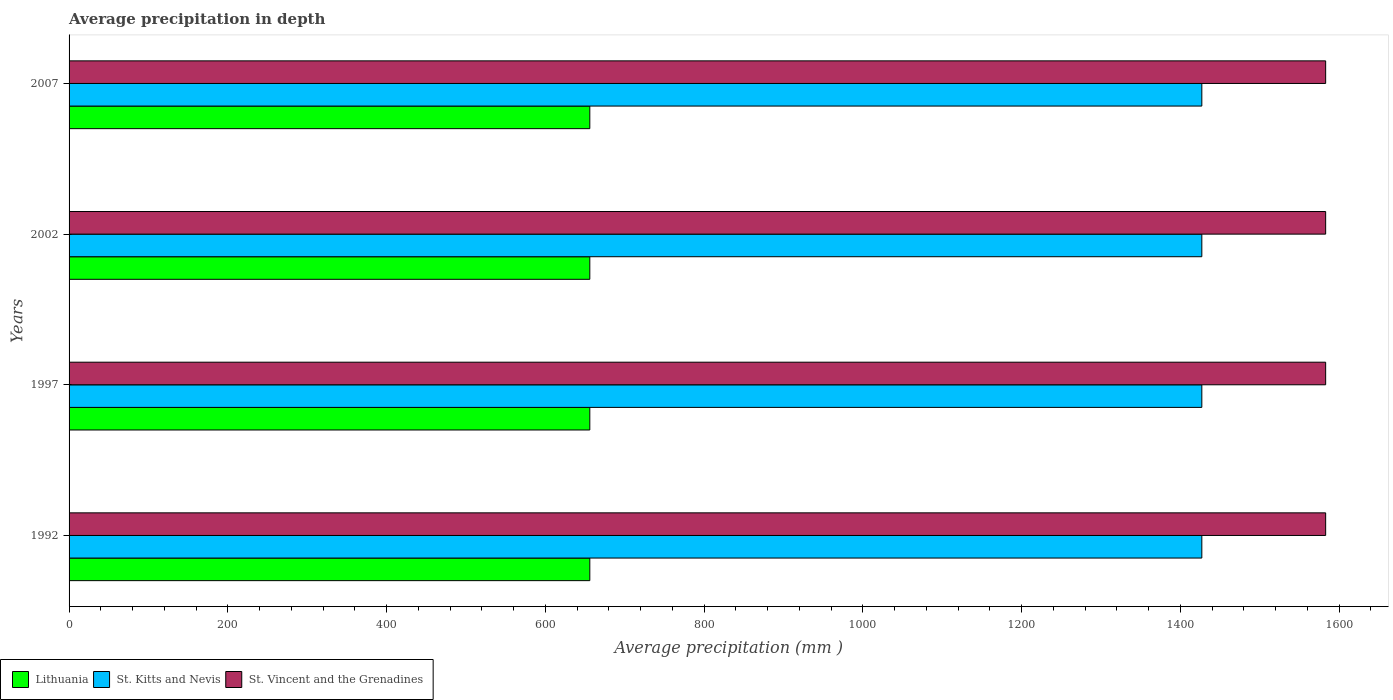How many groups of bars are there?
Keep it short and to the point. 4. What is the label of the 1st group of bars from the top?
Provide a succinct answer. 2007. What is the average precipitation in Lithuania in 2007?
Give a very brief answer. 656. Across all years, what is the maximum average precipitation in St. Kitts and Nevis?
Provide a succinct answer. 1427. Across all years, what is the minimum average precipitation in Lithuania?
Provide a short and direct response. 656. What is the total average precipitation in Lithuania in the graph?
Offer a very short reply. 2624. What is the difference between the average precipitation in St. Kitts and Nevis in 1992 and that in 1997?
Your answer should be compact. 0. What is the difference between the average precipitation in St. Vincent and the Grenadines in 2007 and the average precipitation in St. Kitts and Nevis in 1997?
Give a very brief answer. 156. What is the average average precipitation in St. Vincent and the Grenadines per year?
Keep it short and to the point. 1583. In the year 1997, what is the difference between the average precipitation in Lithuania and average precipitation in St. Kitts and Nevis?
Provide a succinct answer. -771. What is the difference between the highest and the lowest average precipitation in St. Kitts and Nevis?
Make the answer very short. 0. In how many years, is the average precipitation in St. Kitts and Nevis greater than the average average precipitation in St. Kitts and Nevis taken over all years?
Offer a very short reply. 0. Is the sum of the average precipitation in St. Kitts and Nevis in 1997 and 2002 greater than the maximum average precipitation in Lithuania across all years?
Keep it short and to the point. Yes. What does the 1st bar from the top in 2007 represents?
Your answer should be very brief. St. Vincent and the Grenadines. What does the 3rd bar from the bottom in 2002 represents?
Offer a very short reply. St. Vincent and the Grenadines. Are all the bars in the graph horizontal?
Offer a very short reply. Yes. How many years are there in the graph?
Give a very brief answer. 4. Are the values on the major ticks of X-axis written in scientific E-notation?
Your response must be concise. No. Does the graph contain any zero values?
Give a very brief answer. No. Does the graph contain grids?
Provide a short and direct response. No. How are the legend labels stacked?
Make the answer very short. Horizontal. What is the title of the graph?
Your answer should be compact. Average precipitation in depth. What is the label or title of the X-axis?
Provide a succinct answer. Average precipitation (mm ). What is the Average precipitation (mm ) of Lithuania in 1992?
Your response must be concise. 656. What is the Average precipitation (mm ) of St. Kitts and Nevis in 1992?
Your response must be concise. 1427. What is the Average precipitation (mm ) in St. Vincent and the Grenadines in 1992?
Keep it short and to the point. 1583. What is the Average precipitation (mm ) in Lithuania in 1997?
Provide a short and direct response. 656. What is the Average precipitation (mm ) in St. Kitts and Nevis in 1997?
Keep it short and to the point. 1427. What is the Average precipitation (mm ) of St. Vincent and the Grenadines in 1997?
Provide a succinct answer. 1583. What is the Average precipitation (mm ) of Lithuania in 2002?
Give a very brief answer. 656. What is the Average precipitation (mm ) in St. Kitts and Nevis in 2002?
Give a very brief answer. 1427. What is the Average precipitation (mm ) of St. Vincent and the Grenadines in 2002?
Offer a terse response. 1583. What is the Average precipitation (mm ) in Lithuania in 2007?
Your response must be concise. 656. What is the Average precipitation (mm ) in St. Kitts and Nevis in 2007?
Ensure brevity in your answer.  1427. What is the Average precipitation (mm ) of St. Vincent and the Grenadines in 2007?
Ensure brevity in your answer.  1583. Across all years, what is the maximum Average precipitation (mm ) in Lithuania?
Keep it short and to the point. 656. Across all years, what is the maximum Average precipitation (mm ) in St. Kitts and Nevis?
Your answer should be compact. 1427. Across all years, what is the maximum Average precipitation (mm ) in St. Vincent and the Grenadines?
Provide a short and direct response. 1583. Across all years, what is the minimum Average precipitation (mm ) of Lithuania?
Your answer should be very brief. 656. Across all years, what is the minimum Average precipitation (mm ) in St. Kitts and Nevis?
Make the answer very short. 1427. Across all years, what is the minimum Average precipitation (mm ) of St. Vincent and the Grenadines?
Your response must be concise. 1583. What is the total Average precipitation (mm ) in Lithuania in the graph?
Your answer should be compact. 2624. What is the total Average precipitation (mm ) of St. Kitts and Nevis in the graph?
Your response must be concise. 5708. What is the total Average precipitation (mm ) of St. Vincent and the Grenadines in the graph?
Offer a terse response. 6332. What is the difference between the Average precipitation (mm ) in St. Kitts and Nevis in 1992 and that in 1997?
Your answer should be very brief. 0. What is the difference between the Average precipitation (mm ) of St. Vincent and the Grenadines in 1992 and that in 1997?
Keep it short and to the point. 0. What is the difference between the Average precipitation (mm ) in St. Vincent and the Grenadines in 1992 and that in 2002?
Offer a very short reply. 0. What is the difference between the Average precipitation (mm ) of Lithuania in 1992 and that in 2007?
Offer a terse response. 0. What is the difference between the Average precipitation (mm ) of St. Vincent and the Grenadines in 1992 and that in 2007?
Offer a very short reply. 0. What is the difference between the Average precipitation (mm ) in Lithuania in 1997 and that in 2002?
Make the answer very short. 0. What is the difference between the Average precipitation (mm ) of St. Kitts and Nevis in 1997 and that in 2002?
Your answer should be compact. 0. What is the difference between the Average precipitation (mm ) in Lithuania in 1997 and that in 2007?
Offer a terse response. 0. What is the difference between the Average precipitation (mm ) of St. Kitts and Nevis in 1997 and that in 2007?
Provide a succinct answer. 0. What is the difference between the Average precipitation (mm ) of St. Vincent and the Grenadines in 1997 and that in 2007?
Provide a succinct answer. 0. What is the difference between the Average precipitation (mm ) of Lithuania in 2002 and that in 2007?
Provide a succinct answer. 0. What is the difference between the Average precipitation (mm ) in Lithuania in 1992 and the Average precipitation (mm ) in St. Kitts and Nevis in 1997?
Offer a very short reply. -771. What is the difference between the Average precipitation (mm ) in Lithuania in 1992 and the Average precipitation (mm ) in St. Vincent and the Grenadines in 1997?
Ensure brevity in your answer.  -927. What is the difference between the Average precipitation (mm ) of St. Kitts and Nevis in 1992 and the Average precipitation (mm ) of St. Vincent and the Grenadines in 1997?
Your response must be concise. -156. What is the difference between the Average precipitation (mm ) of Lithuania in 1992 and the Average precipitation (mm ) of St. Kitts and Nevis in 2002?
Keep it short and to the point. -771. What is the difference between the Average precipitation (mm ) of Lithuania in 1992 and the Average precipitation (mm ) of St. Vincent and the Grenadines in 2002?
Offer a very short reply. -927. What is the difference between the Average precipitation (mm ) of St. Kitts and Nevis in 1992 and the Average precipitation (mm ) of St. Vincent and the Grenadines in 2002?
Provide a succinct answer. -156. What is the difference between the Average precipitation (mm ) of Lithuania in 1992 and the Average precipitation (mm ) of St. Kitts and Nevis in 2007?
Give a very brief answer. -771. What is the difference between the Average precipitation (mm ) in Lithuania in 1992 and the Average precipitation (mm ) in St. Vincent and the Grenadines in 2007?
Keep it short and to the point. -927. What is the difference between the Average precipitation (mm ) in St. Kitts and Nevis in 1992 and the Average precipitation (mm ) in St. Vincent and the Grenadines in 2007?
Make the answer very short. -156. What is the difference between the Average precipitation (mm ) of Lithuania in 1997 and the Average precipitation (mm ) of St. Kitts and Nevis in 2002?
Provide a succinct answer. -771. What is the difference between the Average precipitation (mm ) in Lithuania in 1997 and the Average precipitation (mm ) in St. Vincent and the Grenadines in 2002?
Offer a terse response. -927. What is the difference between the Average precipitation (mm ) of St. Kitts and Nevis in 1997 and the Average precipitation (mm ) of St. Vincent and the Grenadines in 2002?
Your answer should be compact. -156. What is the difference between the Average precipitation (mm ) of Lithuania in 1997 and the Average precipitation (mm ) of St. Kitts and Nevis in 2007?
Your response must be concise. -771. What is the difference between the Average precipitation (mm ) of Lithuania in 1997 and the Average precipitation (mm ) of St. Vincent and the Grenadines in 2007?
Provide a succinct answer. -927. What is the difference between the Average precipitation (mm ) in St. Kitts and Nevis in 1997 and the Average precipitation (mm ) in St. Vincent and the Grenadines in 2007?
Provide a succinct answer. -156. What is the difference between the Average precipitation (mm ) in Lithuania in 2002 and the Average precipitation (mm ) in St. Kitts and Nevis in 2007?
Offer a very short reply. -771. What is the difference between the Average precipitation (mm ) of Lithuania in 2002 and the Average precipitation (mm ) of St. Vincent and the Grenadines in 2007?
Keep it short and to the point. -927. What is the difference between the Average precipitation (mm ) in St. Kitts and Nevis in 2002 and the Average precipitation (mm ) in St. Vincent and the Grenadines in 2007?
Make the answer very short. -156. What is the average Average precipitation (mm ) of Lithuania per year?
Offer a very short reply. 656. What is the average Average precipitation (mm ) of St. Kitts and Nevis per year?
Your answer should be compact. 1427. What is the average Average precipitation (mm ) of St. Vincent and the Grenadines per year?
Make the answer very short. 1583. In the year 1992, what is the difference between the Average precipitation (mm ) of Lithuania and Average precipitation (mm ) of St. Kitts and Nevis?
Ensure brevity in your answer.  -771. In the year 1992, what is the difference between the Average precipitation (mm ) of Lithuania and Average precipitation (mm ) of St. Vincent and the Grenadines?
Make the answer very short. -927. In the year 1992, what is the difference between the Average precipitation (mm ) of St. Kitts and Nevis and Average precipitation (mm ) of St. Vincent and the Grenadines?
Give a very brief answer. -156. In the year 1997, what is the difference between the Average precipitation (mm ) of Lithuania and Average precipitation (mm ) of St. Kitts and Nevis?
Offer a terse response. -771. In the year 1997, what is the difference between the Average precipitation (mm ) of Lithuania and Average precipitation (mm ) of St. Vincent and the Grenadines?
Offer a terse response. -927. In the year 1997, what is the difference between the Average precipitation (mm ) in St. Kitts and Nevis and Average precipitation (mm ) in St. Vincent and the Grenadines?
Your response must be concise. -156. In the year 2002, what is the difference between the Average precipitation (mm ) in Lithuania and Average precipitation (mm ) in St. Kitts and Nevis?
Give a very brief answer. -771. In the year 2002, what is the difference between the Average precipitation (mm ) of Lithuania and Average precipitation (mm ) of St. Vincent and the Grenadines?
Your answer should be very brief. -927. In the year 2002, what is the difference between the Average precipitation (mm ) in St. Kitts and Nevis and Average precipitation (mm ) in St. Vincent and the Grenadines?
Provide a succinct answer. -156. In the year 2007, what is the difference between the Average precipitation (mm ) in Lithuania and Average precipitation (mm ) in St. Kitts and Nevis?
Your answer should be compact. -771. In the year 2007, what is the difference between the Average precipitation (mm ) in Lithuania and Average precipitation (mm ) in St. Vincent and the Grenadines?
Provide a short and direct response. -927. In the year 2007, what is the difference between the Average precipitation (mm ) of St. Kitts and Nevis and Average precipitation (mm ) of St. Vincent and the Grenadines?
Your response must be concise. -156. What is the ratio of the Average precipitation (mm ) in St. Vincent and the Grenadines in 1992 to that in 1997?
Provide a succinct answer. 1. What is the ratio of the Average precipitation (mm ) of Lithuania in 1992 to that in 2002?
Keep it short and to the point. 1. What is the ratio of the Average precipitation (mm ) in St. Kitts and Nevis in 1992 to that in 2002?
Make the answer very short. 1. What is the ratio of the Average precipitation (mm ) of St. Vincent and the Grenadines in 1992 to that in 2002?
Give a very brief answer. 1. What is the ratio of the Average precipitation (mm ) in St. Vincent and the Grenadines in 1992 to that in 2007?
Offer a terse response. 1. What is the ratio of the Average precipitation (mm ) in St. Vincent and the Grenadines in 1997 to that in 2002?
Make the answer very short. 1. What is the ratio of the Average precipitation (mm ) of St. Kitts and Nevis in 1997 to that in 2007?
Your answer should be very brief. 1. What is the ratio of the Average precipitation (mm ) in St. Vincent and the Grenadines in 1997 to that in 2007?
Your answer should be very brief. 1. What is the ratio of the Average precipitation (mm ) in Lithuania in 2002 to that in 2007?
Make the answer very short. 1. What is the difference between the highest and the second highest Average precipitation (mm ) of St. Vincent and the Grenadines?
Your answer should be very brief. 0. What is the difference between the highest and the lowest Average precipitation (mm ) of St. Vincent and the Grenadines?
Give a very brief answer. 0. 